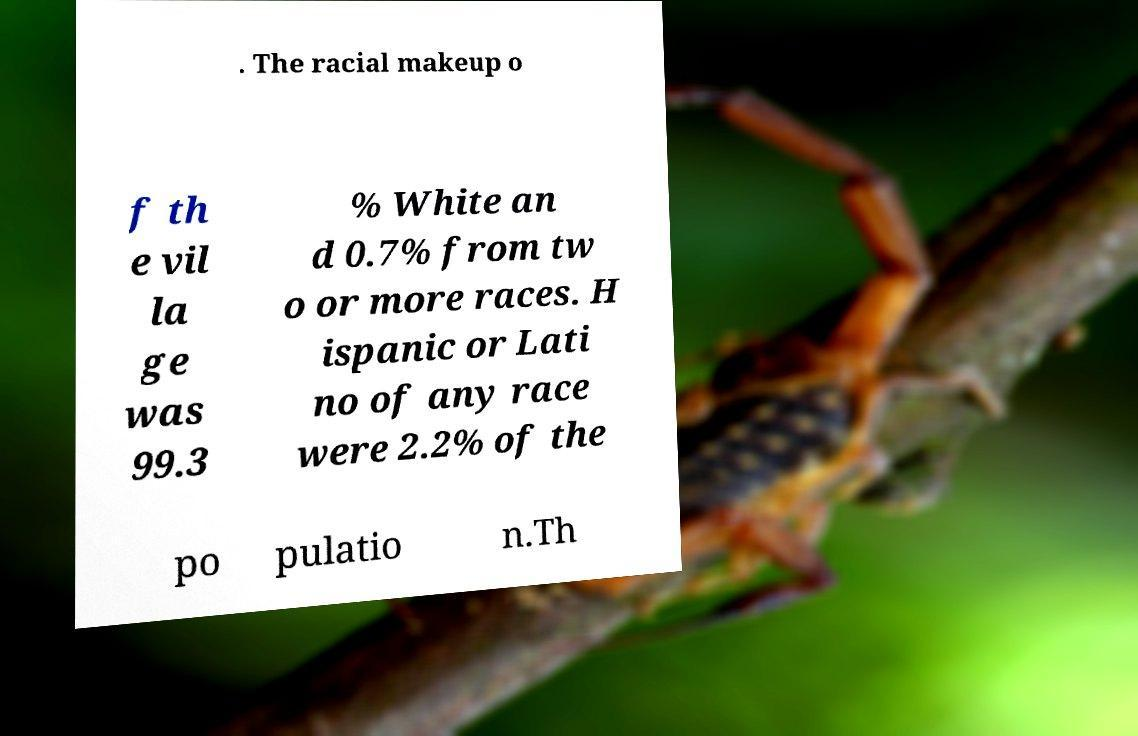What messages or text are displayed in this image? I need them in a readable, typed format. . The racial makeup o f th e vil la ge was 99.3 % White an d 0.7% from tw o or more races. H ispanic or Lati no of any race were 2.2% of the po pulatio n.Th 